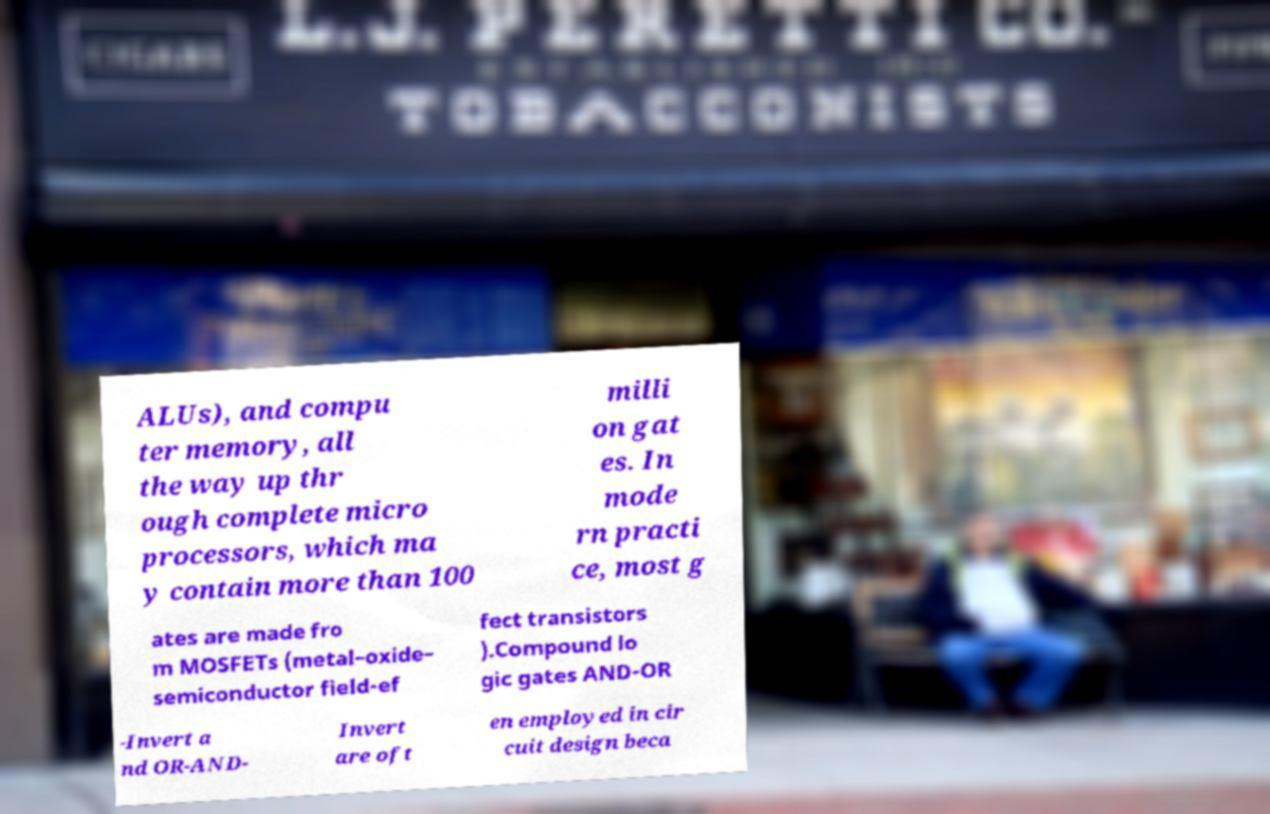For documentation purposes, I need the text within this image transcribed. Could you provide that? ALUs), and compu ter memory, all the way up thr ough complete micro processors, which ma y contain more than 100 milli on gat es. In mode rn practi ce, most g ates are made fro m MOSFETs (metal–oxide– semiconductor field-ef fect transistors ).Compound lo gic gates AND-OR -Invert a nd OR-AND- Invert are oft en employed in cir cuit design beca 